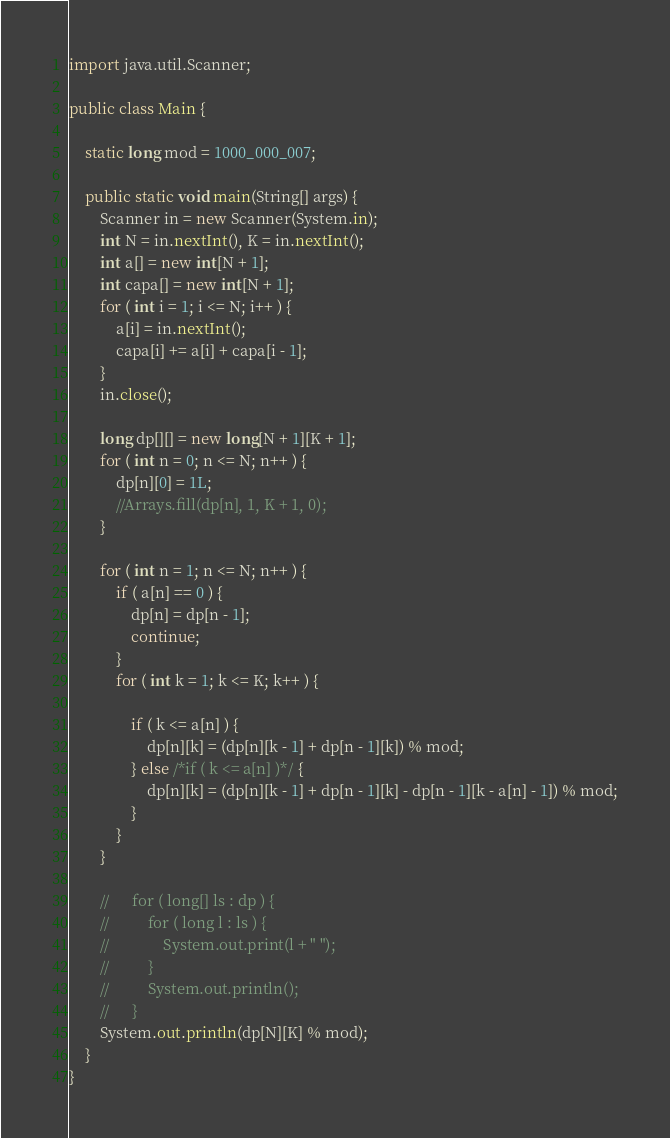Convert code to text. <code><loc_0><loc_0><loc_500><loc_500><_Java_>import java.util.Scanner;

public class Main {

	static long mod = 1000_000_007;

	public static void main(String[] args) {
		Scanner in = new Scanner(System.in);
		int N = in.nextInt(), K = in.nextInt();
		int a[] = new int[N + 1];
		int capa[] = new int[N + 1];
		for ( int i = 1; i <= N; i++ ) {
			a[i] = in.nextInt();
			capa[i] += a[i] + capa[i - 1];
		}
		in.close();

		long dp[][] = new long[N + 1][K + 1];
		for ( int n = 0; n <= N; n++ ) {
			dp[n][0] = 1L;
			//Arrays.fill(dp[n], 1, K + 1, 0);
		}

		for ( int n = 1; n <= N; n++ ) {
			if ( a[n] == 0 ) {
				dp[n] = dp[n - 1];
				continue;
			}
			for ( int k = 1; k <= K; k++ ) {

				if ( k <= a[n] ) {
					dp[n][k] = (dp[n][k - 1] + dp[n - 1][k]) % mod;
				} else /*if ( k <= a[n] )*/ {
					dp[n][k] = (dp[n][k - 1] + dp[n - 1][k] - dp[n - 1][k - a[n] - 1]) % mod;
				}
			}
		}

		//		for ( long[] ls : dp ) {
		//			for ( long l : ls ) {
		//				System.out.print(l + " ");
		//			}
		//			System.out.println();
		//		}
		System.out.println(dp[N][K] % mod);
	}
}
</code> 